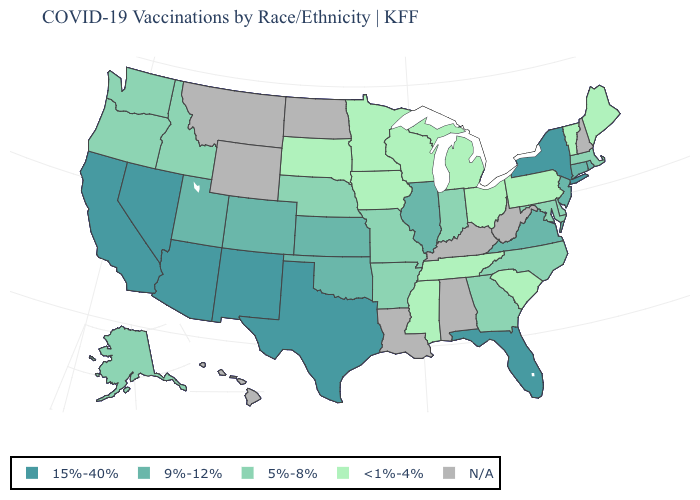Which states have the highest value in the USA?
Quick response, please. Arizona, California, Florida, Nevada, New Mexico, New York, Texas. Among the states that border Vermont , does Massachusetts have the lowest value?
Concise answer only. Yes. Does Vermont have the lowest value in the Northeast?
Give a very brief answer. Yes. What is the value of Nebraska?
Keep it brief. 5%-8%. Among the states that border Oregon , does Nevada have the highest value?
Keep it brief. Yes. Does the map have missing data?
Answer briefly. Yes. Does Kansas have the highest value in the MidWest?
Be succinct. Yes. Does the first symbol in the legend represent the smallest category?
Answer briefly. No. What is the value of Connecticut?
Answer briefly. 9%-12%. What is the value of Utah?
Give a very brief answer. 9%-12%. Which states hav the highest value in the MidWest?
Keep it brief. Illinois, Kansas. 